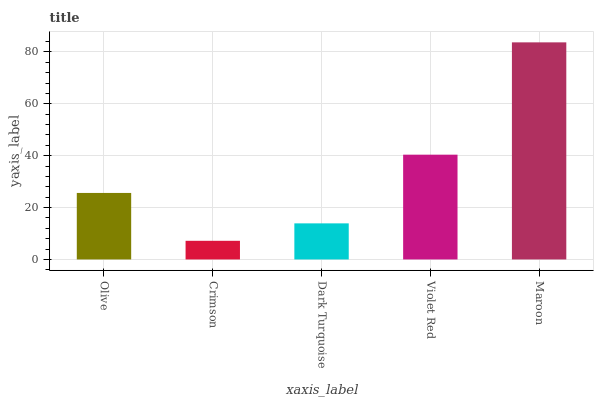Is Crimson the minimum?
Answer yes or no. Yes. Is Maroon the maximum?
Answer yes or no. Yes. Is Dark Turquoise the minimum?
Answer yes or no. No. Is Dark Turquoise the maximum?
Answer yes or no. No. Is Dark Turquoise greater than Crimson?
Answer yes or no. Yes. Is Crimson less than Dark Turquoise?
Answer yes or no. Yes. Is Crimson greater than Dark Turquoise?
Answer yes or no. No. Is Dark Turquoise less than Crimson?
Answer yes or no. No. Is Olive the high median?
Answer yes or no. Yes. Is Olive the low median?
Answer yes or no. Yes. Is Crimson the high median?
Answer yes or no. No. Is Crimson the low median?
Answer yes or no. No. 